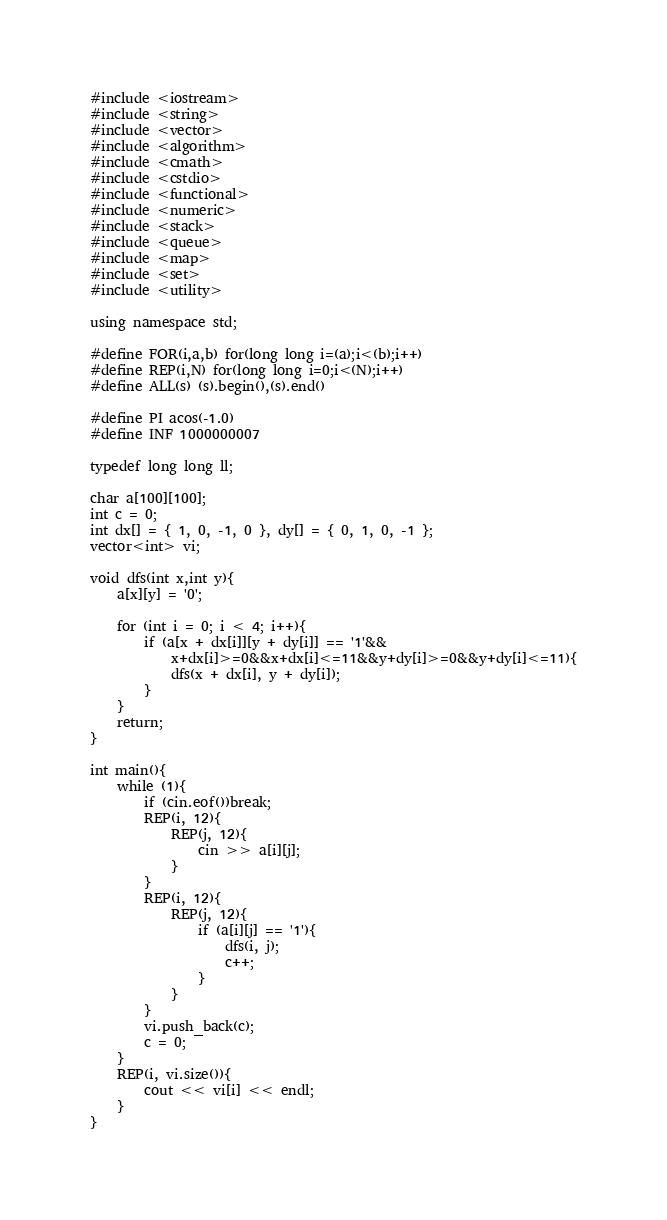<code> <loc_0><loc_0><loc_500><loc_500><_C++_>#include <iostream>
#include <string>
#include <vector>
#include <algorithm>
#include <cmath>
#include <cstdio>
#include <functional>
#include <numeric>
#include <stack>
#include <queue>
#include <map>
#include <set>
#include <utility>

using namespace std;

#define FOR(i,a,b) for(long long i=(a);i<(b);i++)
#define REP(i,N) for(long long i=0;i<(N);i++)
#define ALL(s) (s).begin(),(s).end()

#define PI acos(-1.0)
#define INF 1000000007

typedef long long ll;

char a[100][100];
int c = 0;
int dx[] = { 1, 0, -1, 0 }, dy[] = { 0, 1, 0, -1 };
vector<int> vi;

void dfs(int x,int y){
	a[x][y] = '0';

	for (int i = 0; i < 4; i++){
		if (a[x + dx[i]][y + dy[i]] == '1'&&
			x+dx[i]>=0&&x+dx[i]<=11&&y+dy[i]>=0&&y+dy[i]<=11){
			dfs(x + dx[i], y + dy[i]);
		}
	}
	return;
}

int main(){
	while (1){
		if (cin.eof())break;
		REP(i, 12){
			REP(j, 12){
				cin >> a[i][j];
			}
		}
		REP(i, 12){
			REP(j, 12){
				if (a[i][j] == '1'){
					dfs(i, j);
					c++;
				}
			}
		}
		vi.push_back(c);
		c = 0;
	}
	REP(i, vi.size()){
		cout << vi[i] << endl;
	}
}</code> 